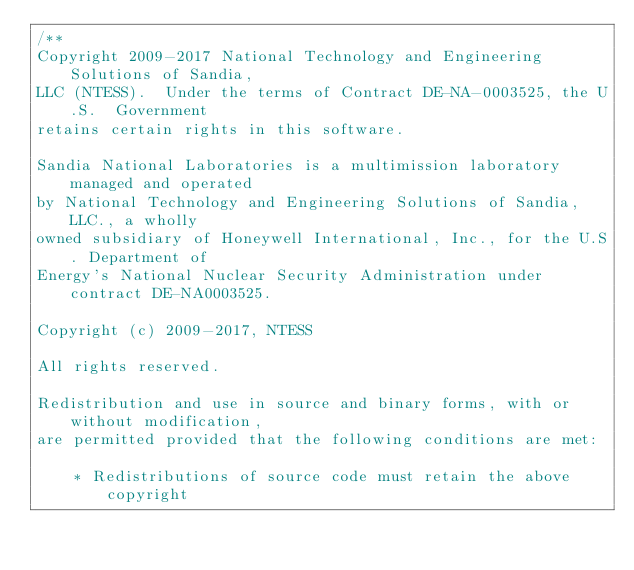Convert code to text. <code><loc_0><loc_0><loc_500><loc_500><_C_>/**
Copyright 2009-2017 National Technology and Engineering Solutions of Sandia, 
LLC (NTESS).  Under the terms of Contract DE-NA-0003525, the U.S.  Government 
retains certain rights in this software.

Sandia National Laboratories is a multimission laboratory managed and operated
by National Technology and Engineering Solutions of Sandia, LLC., a wholly 
owned subsidiary of Honeywell International, Inc., for the U.S. Department of 
Energy's National Nuclear Security Administration under contract DE-NA0003525.

Copyright (c) 2009-2017, NTESS

All rights reserved.

Redistribution and use in source and binary forms, with or without modification, 
are permitted provided that the following conditions are met:

    * Redistributions of source code must retain the above copyright</code> 